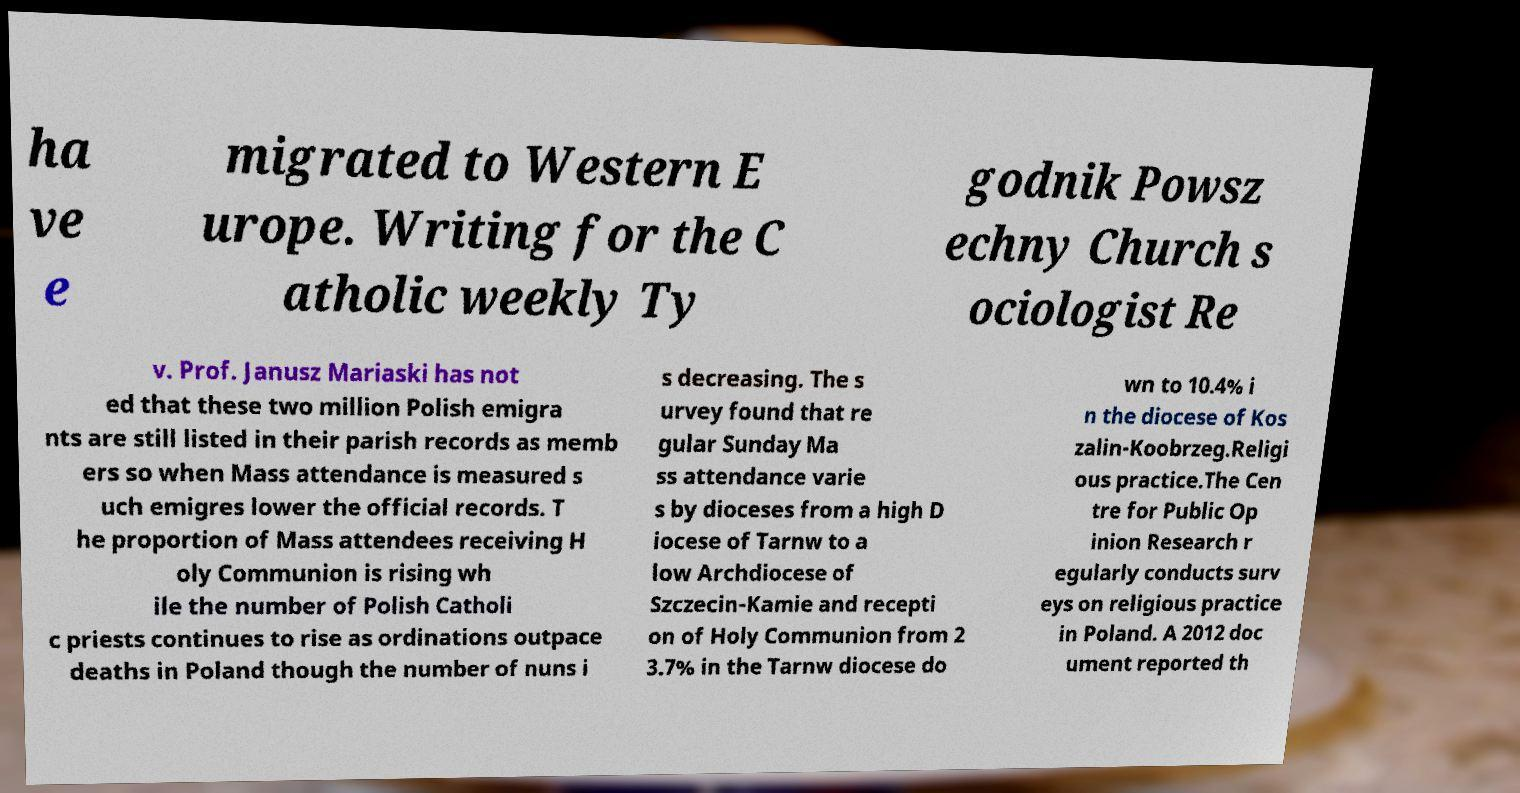What messages or text are displayed in this image? I need them in a readable, typed format. ha ve e migrated to Western E urope. Writing for the C atholic weekly Ty godnik Powsz echny Church s ociologist Re v. Prof. Janusz Mariaski has not ed that these two million Polish emigra nts are still listed in their parish records as memb ers so when Mass attendance is measured s uch emigres lower the official records. T he proportion of Mass attendees receiving H oly Communion is rising wh ile the number of Polish Catholi c priests continues to rise as ordinations outpace deaths in Poland though the number of nuns i s decreasing. The s urvey found that re gular Sunday Ma ss attendance varie s by dioceses from a high D iocese of Tarnw to a low Archdiocese of Szczecin-Kamie and recepti on of Holy Communion from 2 3.7% in the Tarnw diocese do wn to 10.4% i n the diocese of Kos zalin-Koobrzeg.Religi ous practice.The Cen tre for Public Op inion Research r egularly conducts surv eys on religious practice in Poland. A 2012 doc ument reported th 